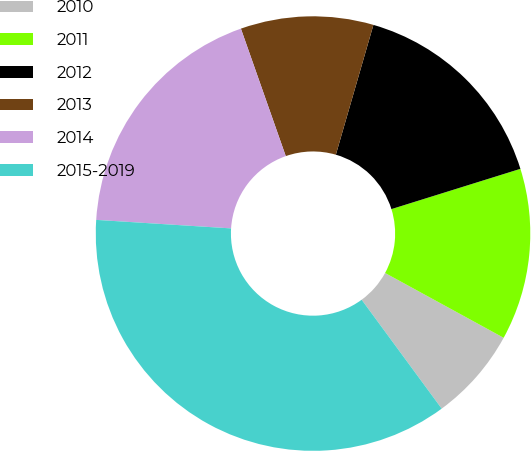Convert chart to OTSL. <chart><loc_0><loc_0><loc_500><loc_500><pie_chart><fcel>2010<fcel>2011<fcel>2012<fcel>2013<fcel>2014<fcel>2015-2019<nl><fcel>6.95%<fcel>12.78%<fcel>15.7%<fcel>9.87%<fcel>18.61%<fcel>36.09%<nl></chart> 